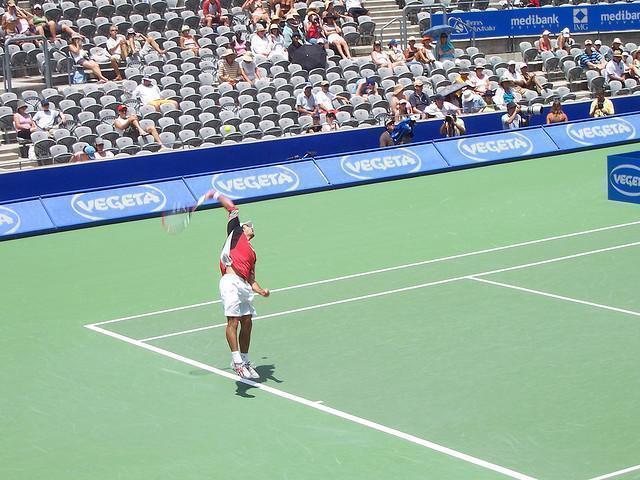What is the brand advertising along the sides of the court?
Make your selection and explain in format: 'Answer: answer
Rationale: rationale.'
Options: Condiment, sun glasses, cars, clothes. Answer: condiment.
Rationale: It is a seasoning put on foods 